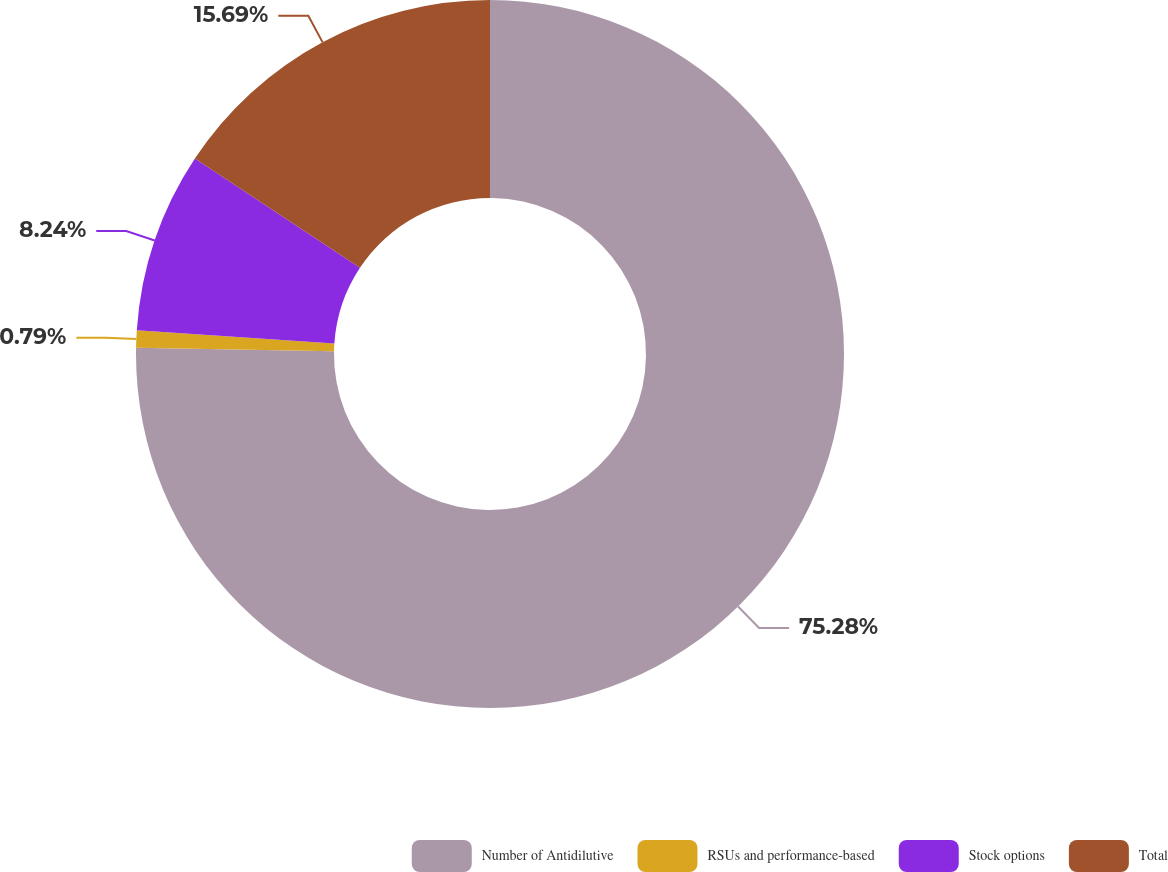Convert chart to OTSL. <chart><loc_0><loc_0><loc_500><loc_500><pie_chart><fcel>Number of Antidilutive<fcel>RSUs and performance-based<fcel>Stock options<fcel>Total<nl><fcel>75.29%<fcel>0.79%<fcel>8.24%<fcel>15.69%<nl></chart> 